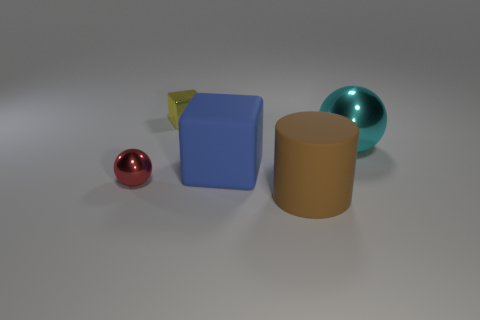What is the color of the matte cube that is the same size as the brown object?
Offer a terse response. Blue. There is a thing to the left of the small yellow block; what is it made of?
Give a very brief answer. Metal. The small ball that is made of the same material as the yellow block is what color?
Keep it short and to the point. Red. How many brown cylinders have the same size as the brown rubber thing?
Offer a terse response. 0. There is a matte object that is behind the brown matte cylinder; is it the same size as the large matte cylinder?
Your answer should be very brief. Yes. What shape is the metal thing that is to the left of the big cyan metal ball and behind the large cube?
Offer a terse response. Cube. There is a yellow cube; are there any metallic blocks behind it?
Give a very brief answer. No. Are there any other things that have the same shape as the big brown thing?
Offer a very short reply. No. Is the shape of the red object the same as the large cyan shiny object?
Your response must be concise. Yes. Is the number of large brown matte objects that are to the left of the brown cylinder the same as the number of small shiny blocks behind the small yellow block?
Keep it short and to the point. Yes. 